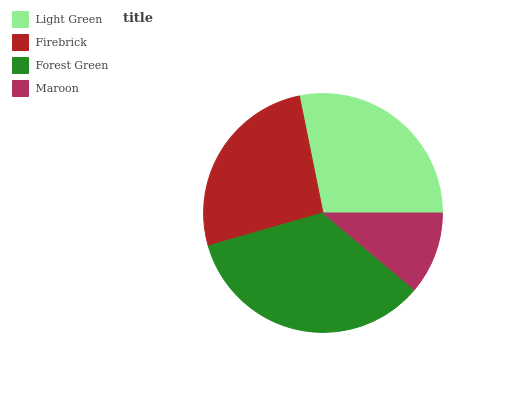Is Maroon the minimum?
Answer yes or no. Yes. Is Forest Green the maximum?
Answer yes or no. Yes. Is Firebrick the minimum?
Answer yes or no. No. Is Firebrick the maximum?
Answer yes or no. No. Is Light Green greater than Firebrick?
Answer yes or no. Yes. Is Firebrick less than Light Green?
Answer yes or no. Yes. Is Firebrick greater than Light Green?
Answer yes or no. No. Is Light Green less than Firebrick?
Answer yes or no. No. Is Light Green the high median?
Answer yes or no. Yes. Is Firebrick the low median?
Answer yes or no. Yes. Is Maroon the high median?
Answer yes or no. No. Is Maroon the low median?
Answer yes or no. No. 